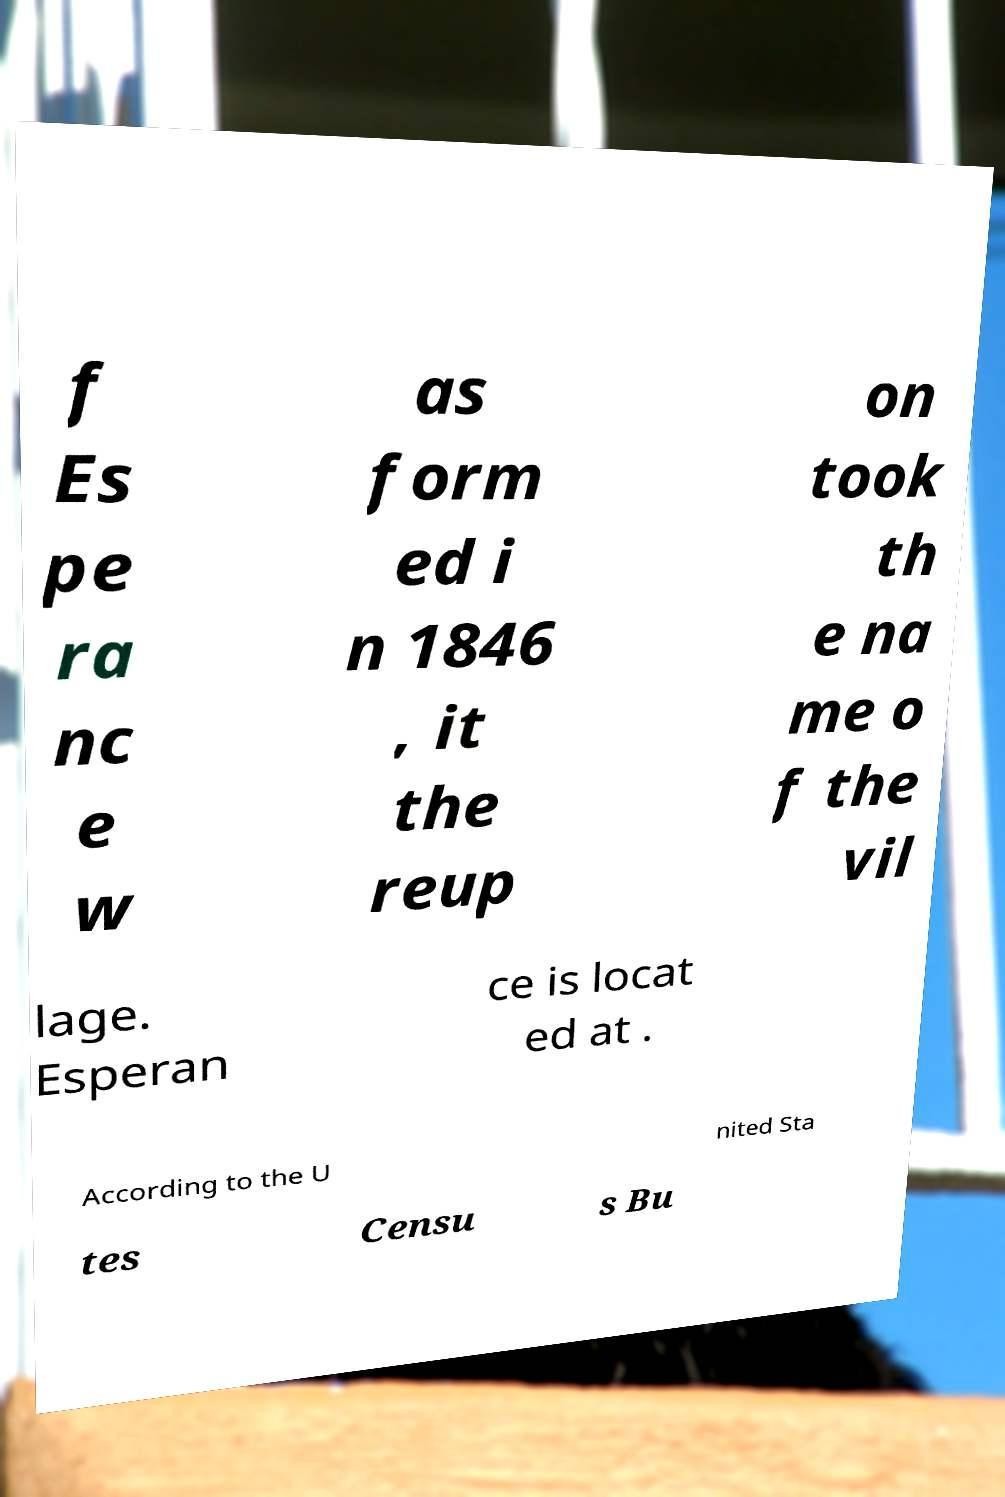Could you extract and type out the text from this image? f Es pe ra nc e w as form ed i n 1846 , it the reup on took th e na me o f the vil lage. Esperan ce is locat ed at . According to the U nited Sta tes Censu s Bu 